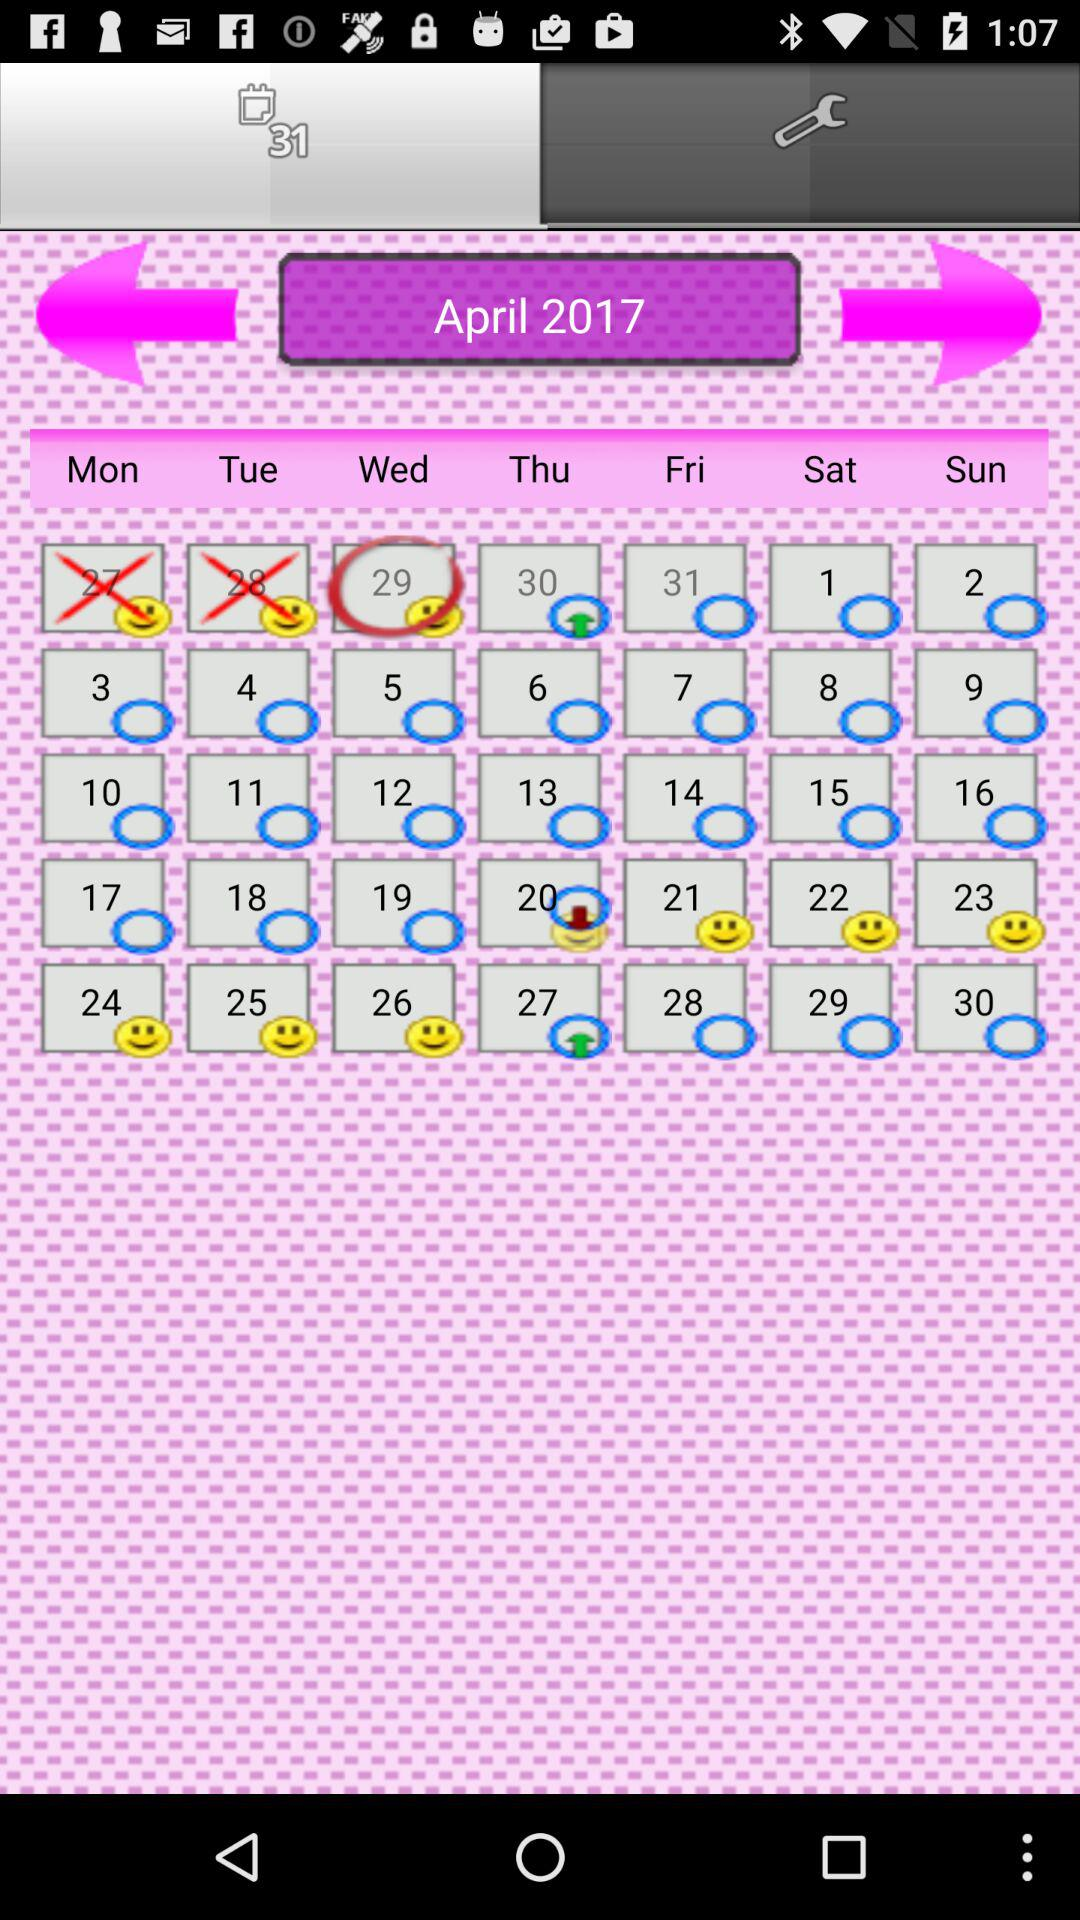How many calendar entries are on April 29, 2017?
When the provided information is insufficient, respond with <no answer>. <no answer> 